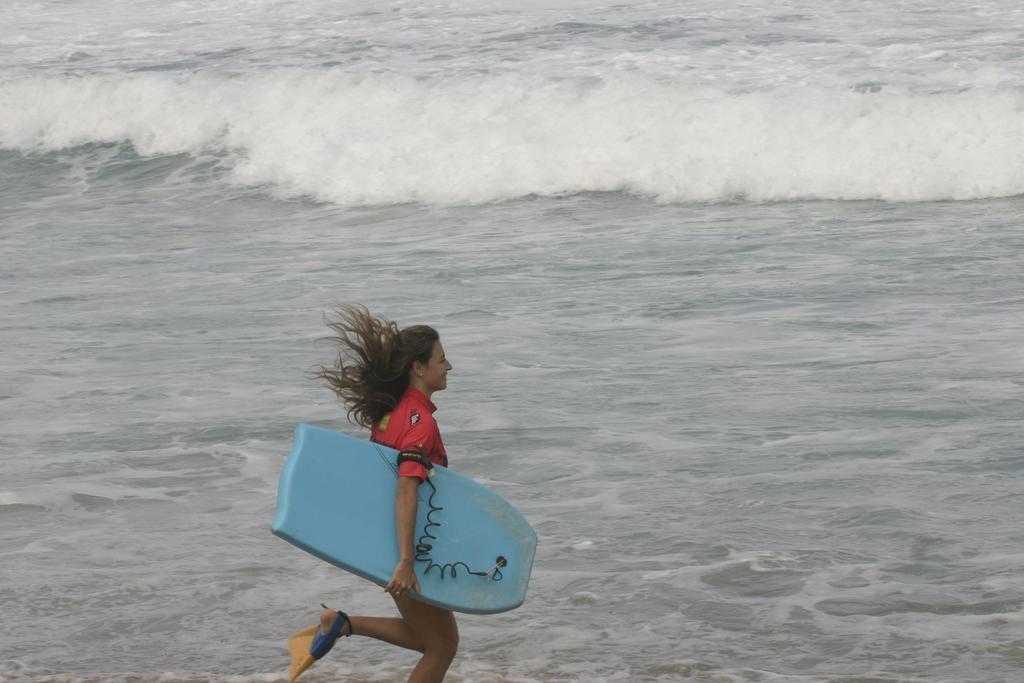Please provide a concise description of this image. In this picture we can see a woman who is holding a surfing board with her hand. And this is sea. 